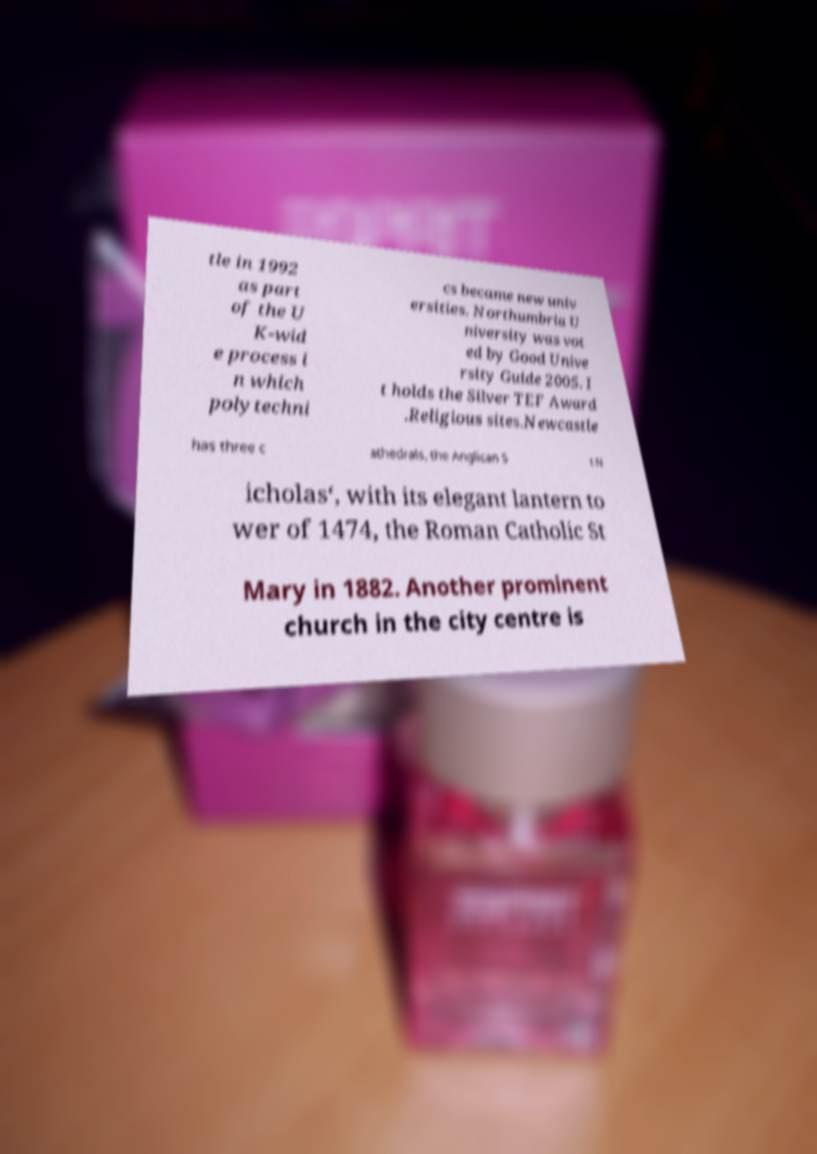There's text embedded in this image that I need extracted. Can you transcribe it verbatim? tle in 1992 as part of the U K-wid e process i n which polytechni cs became new univ ersities. Northumbria U niversity was vot ed by Good Unive rsity Guide 2005. I t holds the Silver TEF Award .Religious sites.Newcastle has three c athedrals, the Anglican S t N icholas‘, with its elegant lantern to wer of 1474, the Roman Catholic St Mary in 1882. Another prominent church in the city centre is 